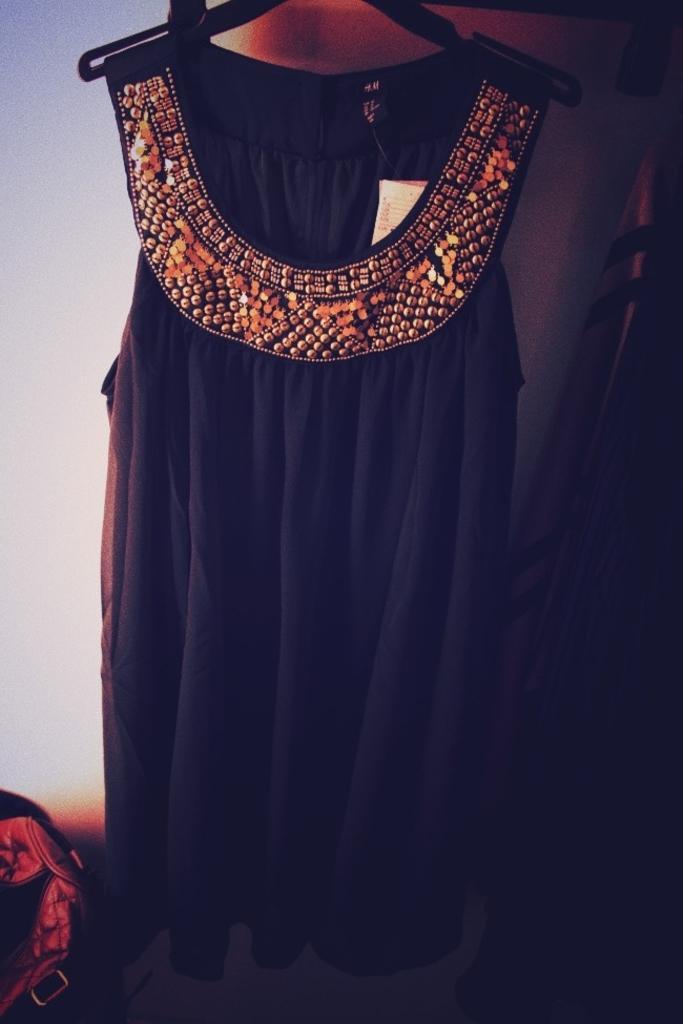Describe this image in one or two sentences. In this picture I can see a dress in the middle, on the left side it looks like a bag. 